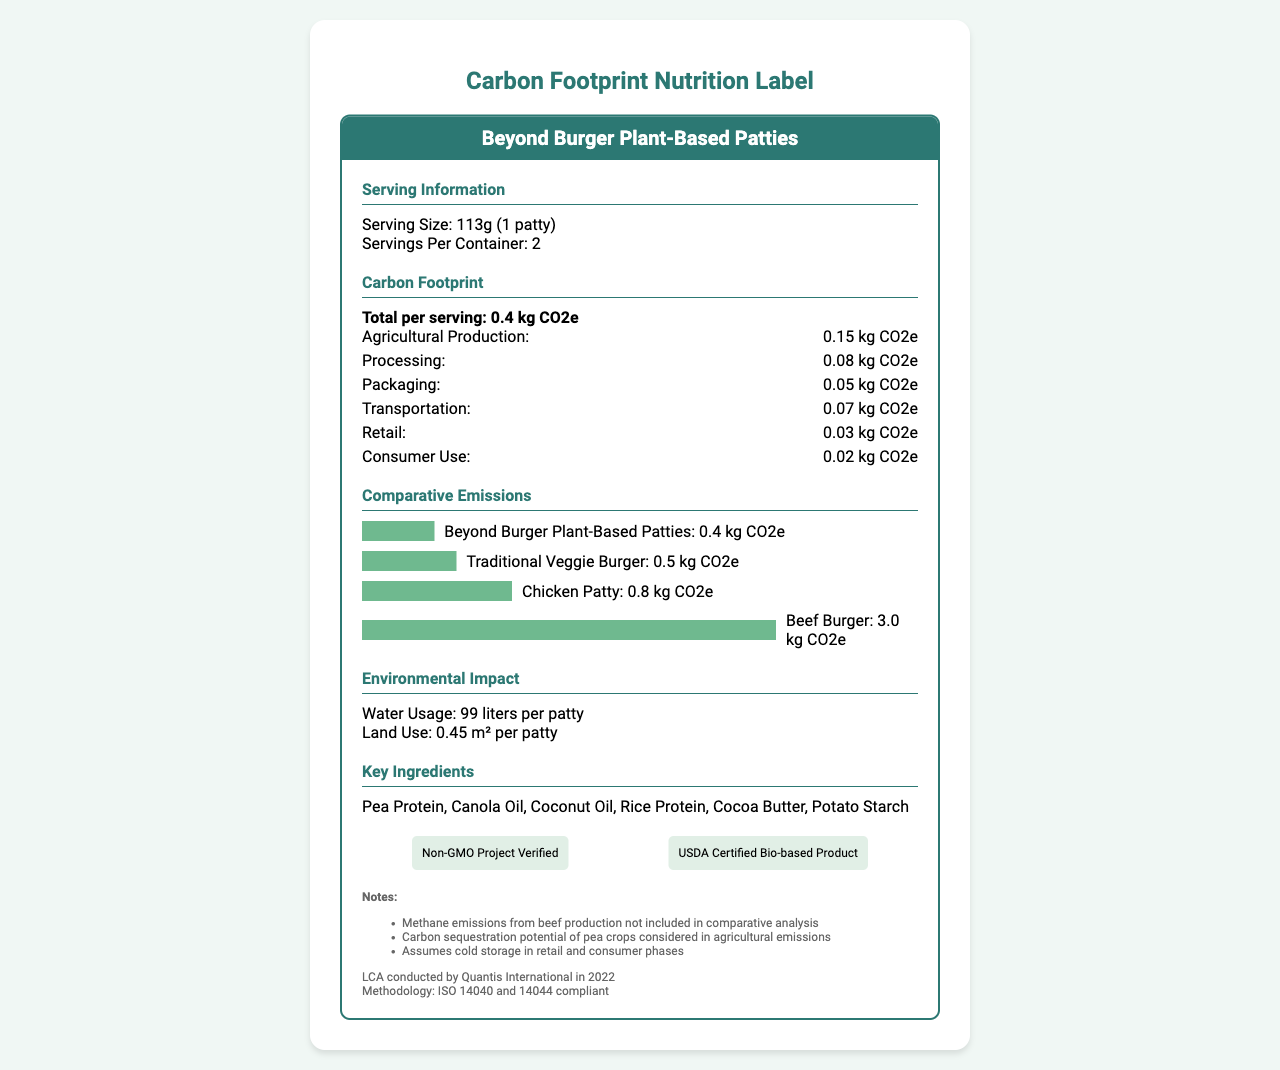what is the serving size? The serving size is explicitly mentioned under the Serving Information section as "113g (1 patty)."
Answer: 113g (1 patty) how many servings are there per container? The number of servings per container is listed as 2 under the Serving Information section.
Answer: 2 what is the total carbon footprint per serving? The total carbon footprint per serving is given as 0.4 kg CO2e under the Carbon Footprint section.
Answer: 0.4 kg CO2e what is the carbon footprint for agricultural production per serving? The breakdown of the carbon footprint for agricultural production per serving is listed as 0.15 kg CO2e in the Carbon Footprint section.
Answer: 0.15 kg CO2e which key ingredient is the first on the list? The first key ingredient listed is Pea Protein in the Key Ingredients section.
Answer: Pea Protein what is the water usage per patty? The water usage per patty is mentioned as 99 liters in the Environmental Impact section.
Answer: 99 liters how does the carbon footprint of the Beyond Burger compare to a beef burger? The Comparative Emissions section shows that the Beyond Burger has a carbon footprint of 0.4 kg CO2e, whereas a beef burger has 3.0 kg CO2e.
Answer: 0.4 kg CO2e for Beyond Burger and 3.0 kg CO2e for beef burger which organization conducted the lifecycle assessment? The lifecycle assessment was conducted by Quantis International as stated in the Notes section.
Answer: Quantis International which certification ensures that the product is non-GMO? The Non-GMO Project Verified certification ensures that the product is non-GMO, listed in the Environmental Certifications section.
Answer: Non-GMO Project Verified what sustainability initiatives does the company support? The sustainability initiatives are listed and include 100% recyclable packaging, commitment to net-zero emissions by 2035, and partnering with regenerative agriculture projects, found under the Sustainability Initiatives section.
Answer: 100% recyclable packaging, commitment to net-zero emissions by 2035, partnering with regenerative agriculture projects how much land is used per patty? The land use per patty is mentioned as 0.45 m² per patty in the Environmental Impact section.
Answer: 0.45 m² per patty how much can one save in carbon tax by choosing this patty? The carbon tax savings is listed as $0.012 per patty in the Policy Relevance section.
Answer: $0.012 per patty how does the centerpiece burger compare to a traditional veggie burger in terms of carbon footprint? The Comparative Emissions section shows that the Beyond Burger (0.4 kg CO2e) has a lower carbon footprint compared to a traditional veggie burger (0.5 kg CO2e).
Answer: A does this burger support the 1.5°C pathway targets of the Paris Agreement? The Policy Relevance section clearly states that the product supports 1.5°C pathway targets of the Paris Agreement.
Answer: Yes please summarize the main environmental benefits and features of the Beyond Burger. The Beyond Burger presents itself as a sustainable alternative with significantly lower carbon emissions compared to traditional meat. It also incorporates multiple environmental certifications and sustainability efforts which contribute to broader climate goals and reduction of carbon footprints.
Answer: The Beyond Burger offers significant environmental benefits including a low carbon footprint of 0.4 kg CO2e per patty, much lower than traditional meat and veggie alternatives. It uses 99 liters of water and 0.45 m² of land per patty. The product is also Non-GMO Project Verified and USDA Certified Bio-based. The sustainability initiatives include 100% recyclable packaging, commitment to net-zero emissions by 2035, and partnerships with regenerative agriculture projects. what was the methodology used in the lifecycle assessment? As indicated in the Notes section, the lifecycle assessment was conducted using a methodology that adheres to ISO 14040 and 14044 standards.
Answer: ISO 14040 and 14044 compliant what is the carbon footprint for consumer use per serving? The consumer use carbon footprint is listed as 0.02 kg CO2e under the Carbon Footprint section.
Answer: 0.02 kg CO2e how many key ingredients are mentioned in the label? The Key Ingredients section lists six key ingredients: Pea Protein, Canola Oil, Coconut Oil, Rice Protein, Cocoa Butter, and Potato Starch.
Answer: 6 how much carbon emissions can be reduced annually by replacing 2 beef burgers per week with this patty? According to the Emissions Reduction Potential section, 0.15 metric tons CO2e per person can be reduced annually by replacing 2 beef burgers per week.
Answer: 0.15 metric tons CO2e per person does the carbon footprint include methane emissions from beef production? The Notes section explicitly mentions that methane emissions from beef production are not included in the comparative analysis.
Answer: No what specific year was the lifecycle assessment conducted? The lifecycle assessment was conducted in the year 2022 according to the Notes section.
Answer: 2022 what impact does the cold storage assumption have on emissions? The Notes section states that cold storage is assumed in the retail and consumer phases, but it does not provide specific details on the impact of this assumption on emissions.
Answer: Not enough information 